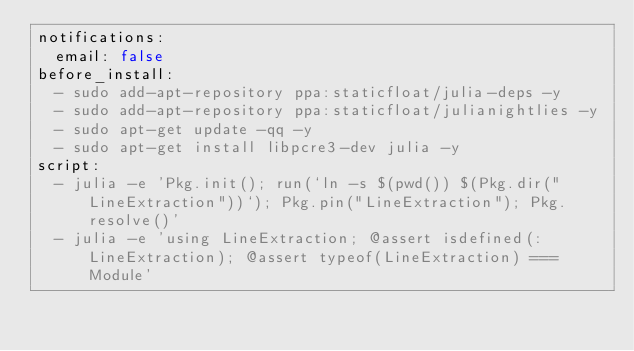<code> <loc_0><loc_0><loc_500><loc_500><_YAML_>notifications:
  email: false
before_install:
  - sudo add-apt-repository ppa:staticfloat/julia-deps -y
  - sudo add-apt-repository ppa:staticfloat/julianightlies -y
  - sudo apt-get update -qq -y
  - sudo apt-get install libpcre3-dev julia -y
script:
  - julia -e 'Pkg.init(); run(`ln -s $(pwd()) $(Pkg.dir("LineExtraction"))`); Pkg.pin("LineExtraction"); Pkg.resolve()'
  - julia -e 'using LineExtraction; @assert isdefined(:LineExtraction); @assert typeof(LineExtraction) === Module'
</code> 